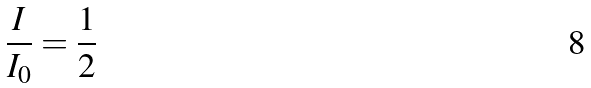<formula> <loc_0><loc_0><loc_500><loc_500>\frac { I } { I _ { 0 } } = \frac { 1 } { 2 }</formula> 